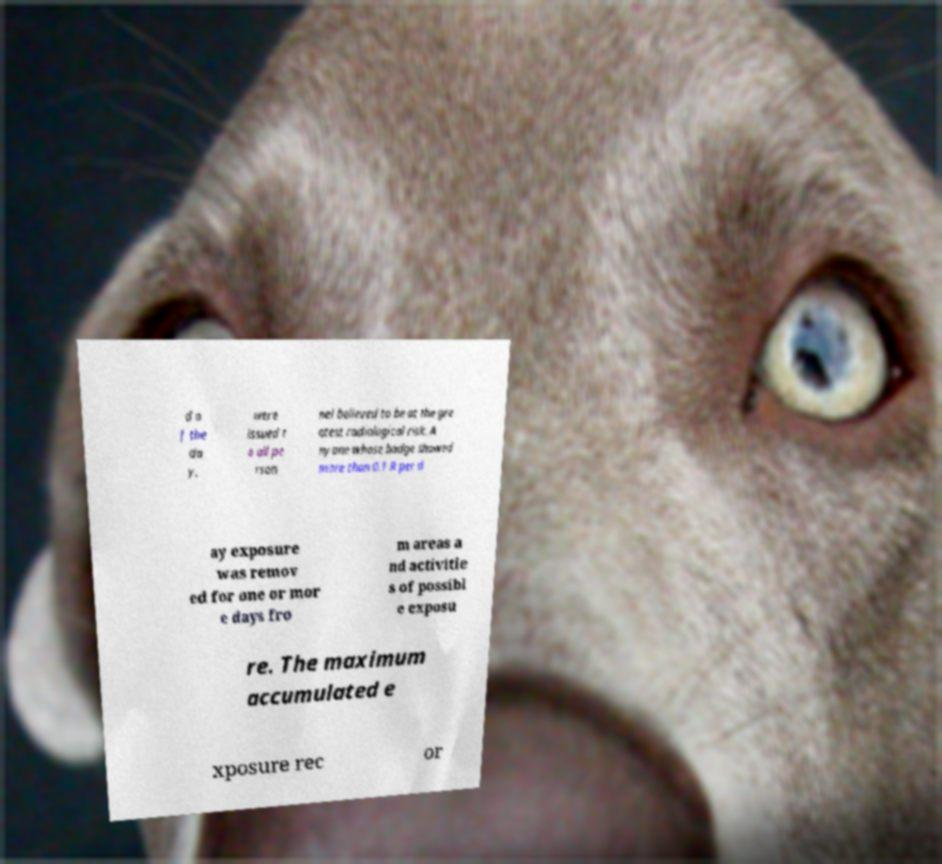What messages or text are displayed in this image? I need them in a readable, typed format. d o f the da y, were issued t o all pe rson nel believed to be at the gre atest radiological risk. A nyone whose badge showed more than 0.1 R per d ay exposure was remov ed for one or mor e days fro m areas a nd activitie s of possibl e exposu re. The maximum accumulated e xposure rec or 